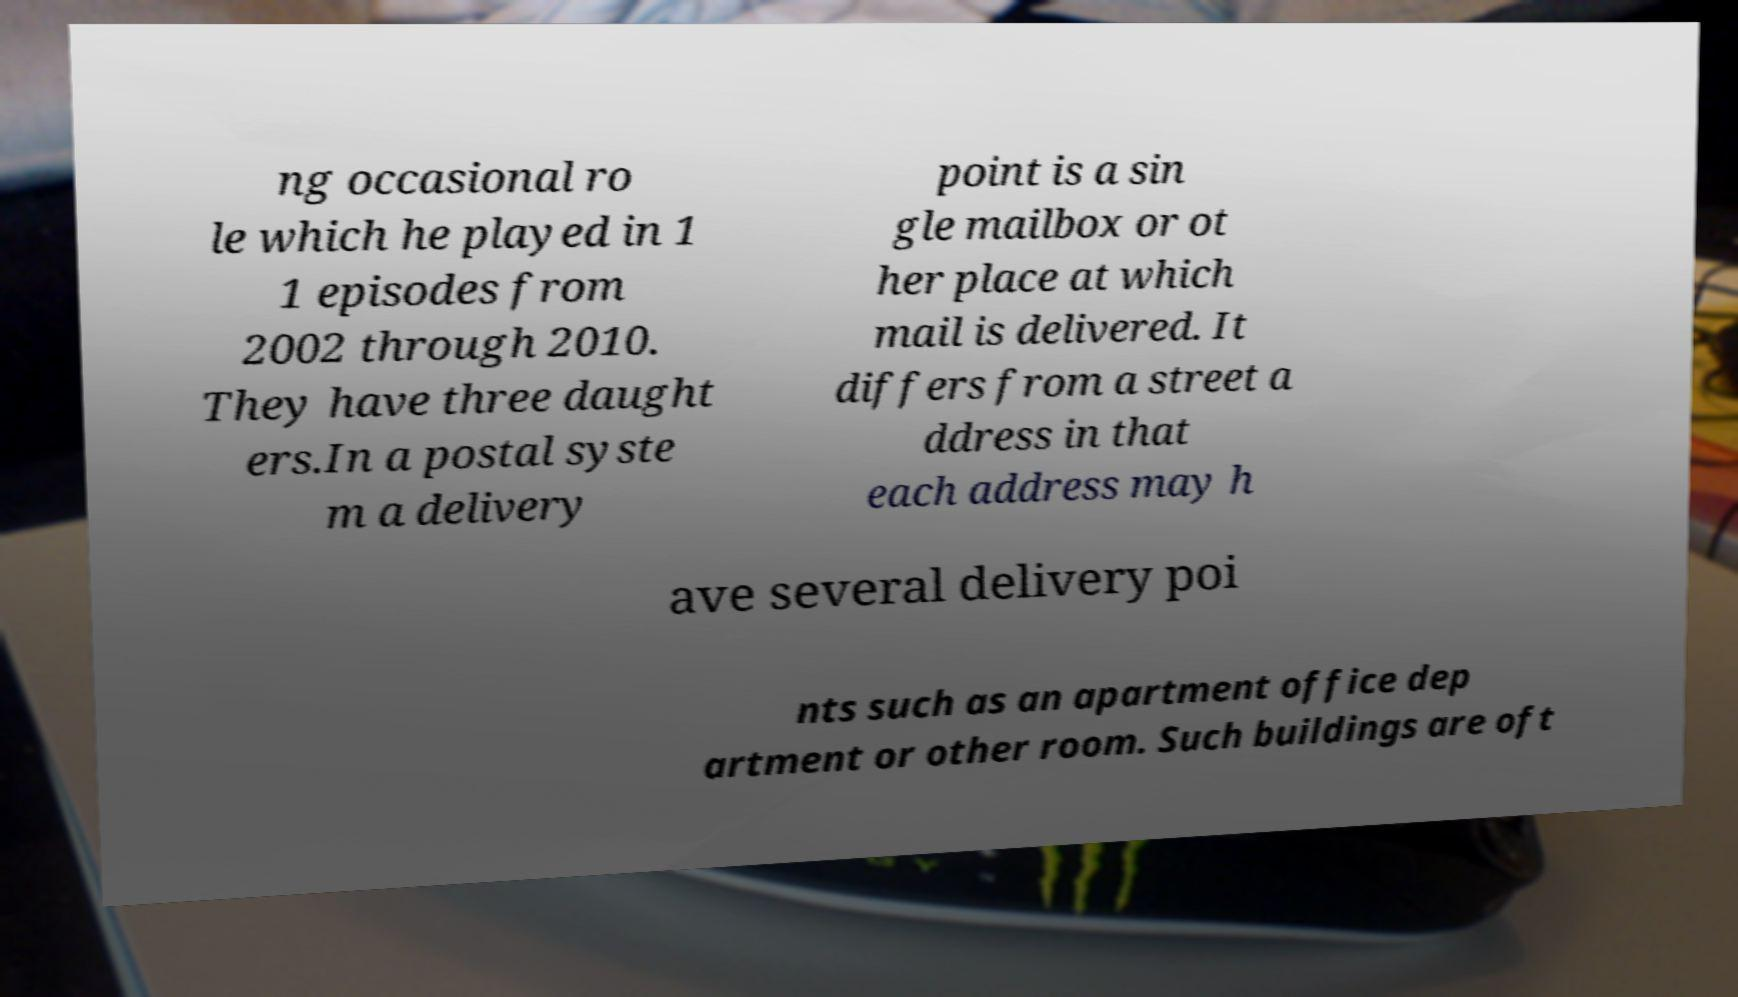Can you read and provide the text displayed in the image?This photo seems to have some interesting text. Can you extract and type it out for me? ng occasional ro le which he played in 1 1 episodes from 2002 through 2010. They have three daught ers.In a postal syste m a delivery point is a sin gle mailbox or ot her place at which mail is delivered. It differs from a street a ddress in that each address may h ave several delivery poi nts such as an apartment office dep artment or other room. Such buildings are oft 